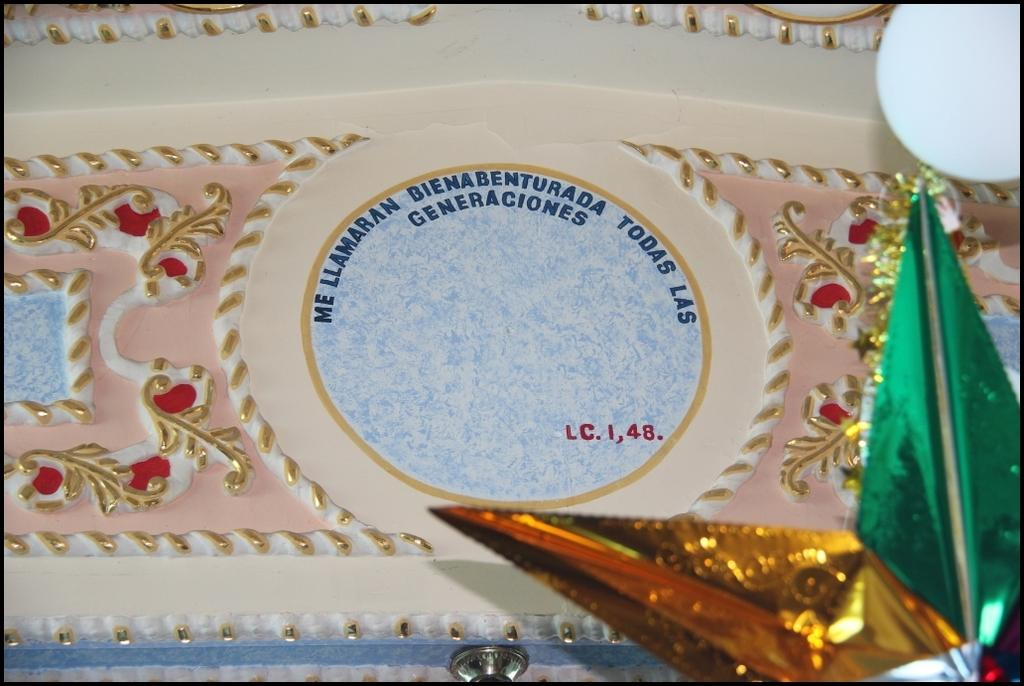What can be seen on the wall in the image? There is text and design on the wall in the image. Can you describe any specific details about the wall? The wall features a star in the bottom right corner of the image. What type of oatmeal is being served in the image? There is no oatmeal present in the image. Who is the manager of the area depicted in the image? The image does not provide information about a manager or any specific location. 